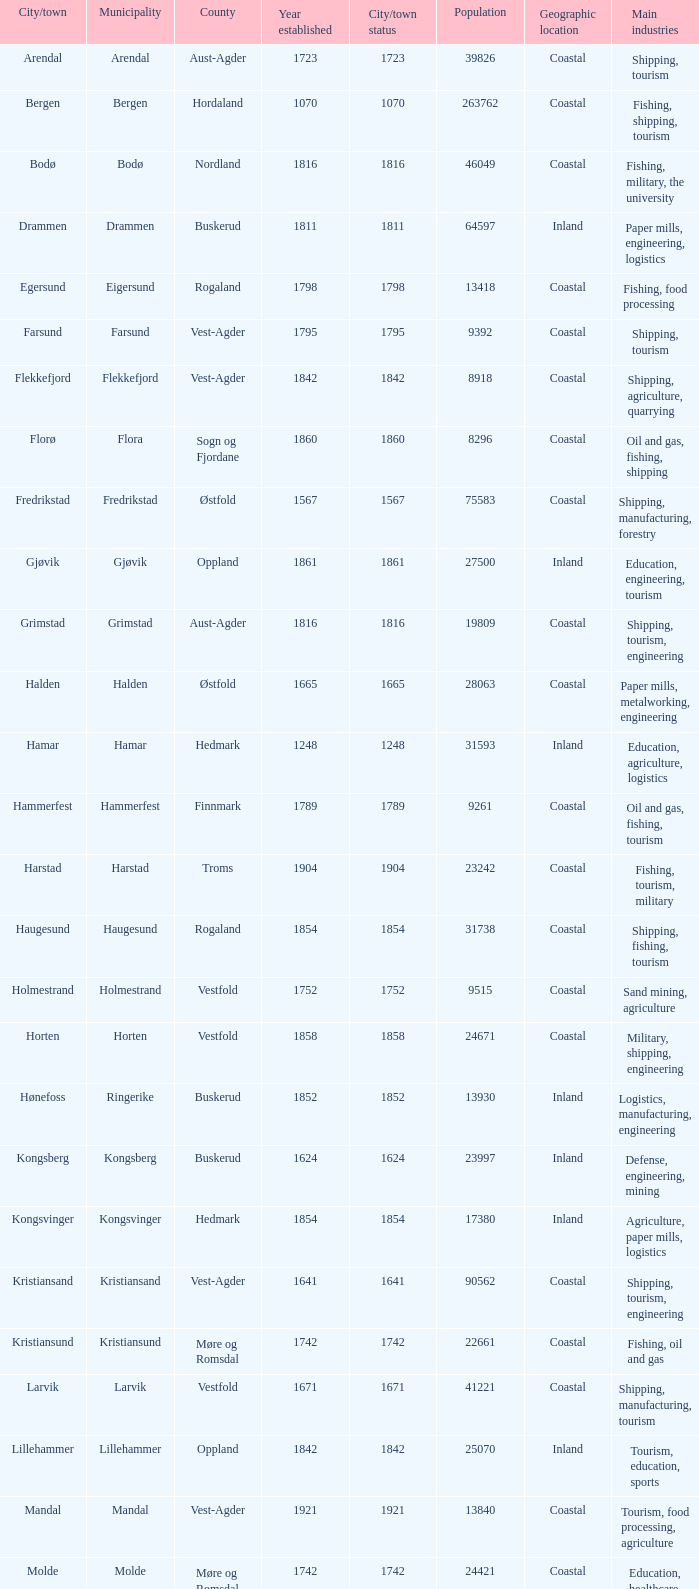Parse the table in full. {'header': ['City/town', 'Municipality', 'County', 'Year established', 'City/town status', 'Population', 'Geographic location', 'Main industries'], 'rows': [['Arendal', 'Arendal', 'Aust-Agder', '1723', '1723', '39826', 'Coastal', 'Shipping, tourism'], ['Bergen', 'Bergen', 'Hordaland', '1070', '1070', '263762', 'Coastal', 'Fishing, shipping, tourism'], ['Bodø', 'Bodø', 'Nordland', '1816', '1816', '46049', 'Coastal', 'Fishing, military, the university'], ['Drammen', 'Drammen', 'Buskerud', '1811', '1811', '64597', 'Inland', 'Paper mills, engineering, logistics'], ['Egersund', 'Eigersund', 'Rogaland', '1798', '1798', '13418', 'Coastal', 'Fishing, food processing'], ['Farsund', 'Farsund', 'Vest-Agder', '1795', '1795', '9392', 'Coastal', 'Shipping, tourism'], ['Flekkefjord', 'Flekkefjord', 'Vest-Agder', '1842', '1842', '8918', 'Coastal', 'Shipping, agriculture, quarrying'], ['Florø', 'Flora', 'Sogn og Fjordane', '1860', '1860', '8296', 'Coastal', 'Oil and gas, fishing, shipping'], ['Fredrikstad', 'Fredrikstad', 'Østfold', '1567', '1567', '75583', 'Coastal', 'Shipping, manufacturing, forestry'], ['Gjøvik', 'Gjøvik', 'Oppland', '1861', '1861', '27500', 'Inland', 'Education, engineering, tourism'], ['Grimstad', 'Grimstad', 'Aust-Agder', '1816', '1816', '19809', 'Coastal', 'Shipping, tourism, engineering'], ['Halden', 'Halden', 'Østfold', '1665', '1665', '28063', 'Coastal', 'Paper mills, metalworking, engineering'], ['Hamar', 'Hamar', 'Hedmark', '1248', '1248', '31593', 'Inland', 'Education, agriculture, logistics'], ['Hammerfest', 'Hammerfest', 'Finnmark', '1789', '1789', '9261', 'Coastal', 'Oil and gas, fishing, tourism'], ['Harstad', 'Harstad', 'Troms', '1904', '1904', '23242', 'Coastal', 'Fishing, tourism, military'], ['Haugesund', 'Haugesund', 'Rogaland', '1854', '1854', '31738', 'Coastal', 'Shipping, fishing, tourism'], ['Holmestrand', 'Holmestrand', 'Vestfold', '1752', '1752', '9515', 'Coastal', 'Sand mining, agriculture'], ['Horten', 'Horten', 'Vestfold', '1858', '1858', '24671', 'Coastal', 'Military, shipping, engineering'], ['Hønefoss', 'Ringerike', 'Buskerud', '1852', '1852', '13930', 'Inland', 'Logistics, manufacturing, engineering'], ['Kongsberg', 'Kongsberg', 'Buskerud', '1624', '1624', '23997', 'Inland', 'Defense, engineering, mining'], ['Kongsvinger', 'Kongsvinger', 'Hedmark', '1854', '1854', '17380', 'Inland', 'Agriculture, paper mills, logistics'], ['Kristiansand', 'Kristiansand', 'Vest-Agder', '1641', '1641', '90562', 'Coastal', 'Shipping, tourism, engineering'], ['Kristiansund', 'Kristiansund', 'Møre og Romsdal', '1742', '1742', '22661', 'Coastal', 'Fishing, oil and gas'], ['Larvik', 'Larvik', 'Vestfold', '1671', '1671', '41221', 'Coastal', 'Shipping, manufacturing, tourism'], ['Lillehammer', 'Lillehammer', 'Oppland', '1842', '1842', '25070', 'Inland', 'Tourism, education, sports'], ['Mandal', 'Mandal', 'Vest-Agder', '1921', '1921', '13840', 'Coastal', 'Tourism, food processing, agriculture'], ['Molde', 'Molde', 'Møre og Romsdal', '1742', '1742', '24421', 'Coastal', 'Education, healthcare, tourism'], ['Moss', 'Moss', 'Østfold', '1720', '1720', '28800', 'Coastal', 'Shipping, manufacturing, logistics'], ['Namsos', 'Namsos', 'Nord-Trøndelag', '1845', '1845', '12426', 'Coastal', 'Fishing, paper mills, logistics'], ['Narvik', 'Narvik', 'Nordland', '1902', '1902', '18512', 'Coastal', 'Mining, shipping, tourism'], ['Notodden', 'Notodden', 'Telemark', '1913', '1913', '12359', 'Inland', 'Industrial heritage, hydroelectric power'], ['Oslo', 'Oslo', 'Oslo', '1000', '1000', '613285', 'Coastal', 'Finance, technology, shipping'], ['Porsgrunn', 'Porsgrunn', 'Telemark', '1842', '1842', '33550', 'Coastal', 'Chemicals, metalworking, logistics'], ['Risør', 'Risør', 'Aust-Agder', '1630', '1630', '6938', 'Coastal', 'Shipping, tourism, small-scale industries'], ['Sandefjord', 'Sandefjord', 'Vestfold', '1845', '1845', '42333', 'Coastal', 'Shipping, fishing, tourism'], ['Sandnes', 'Sandnes', 'Rogaland', '1860', '1860', '63032', 'Coastal', 'Oil and gas, engineering, tourism'], ['Sarpsborg', 'Sarpsborg', 'Østfold', '1016', '1016', '50115', 'Coastal', 'Paper mills, logistics, manufacturing'], ['Skien', 'Skien', 'Telemark', '1000', '1000', '72537', 'Inland', 'Shipping, manufacturing, healthcare'], ['Stavanger', 'Stavanger', 'Rogaland', '1125', '1125', '127506', 'Coastal', 'Oil and gas, engineering, tourism'], ['Steinkjer', 'Steinkjer', 'Nord-Trøndelag', '1857', '1857', '20672', 'Inland', 'Agriculture, logistics, education'], ['Søgne', 'Søgne', 'Vest-Agder', '1913', '1913', '12509', 'Coastal', 'Shipping, fishing, agriculture'], ['Tromsø', 'Tromsø', 'Troms', '1794', '1794', '64782', 'Coastal', 'Tourism, research, education'], ['Trondheim', 'Trondheim', 'Sør-Trøndelag', '997', '997', '176348', 'Coastal', 'Education, technology, healthcare'], ['Tønsberg', 'Tønsberg', 'Vestfold', '871', '871', '38914', 'Coastal', 'Shipping, tourism, agriculture'], ['Vadsø', 'Vadsø', 'Finnmark', '1833', '1833', '6187', 'Coastal', 'Fishing, administration, logistics'], ['Vardø', 'Vardø', 'Finnmark', '1789', '1789', '2396', 'Coastal', 'Fishing, tourism, administration'], ['Vennesla', 'Vennesla', 'Vest-Agder', '1964', '1964', '13116', 'Inland', 'Woodworking, agriculture, logistics']]} What are the cities/towns located in the municipality of Moss? Moss. 